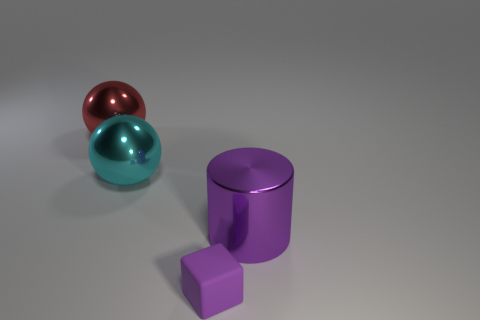Add 2 small purple matte things. How many objects exist? 6 Subtract all cubes. How many objects are left? 3 Subtract all small blue rubber objects. Subtract all matte blocks. How many objects are left? 3 Add 4 large shiny cylinders. How many large shiny cylinders are left? 5 Add 4 large gray balls. How many large gray balls exist? 4 Subtract 0 brown cylinders. How many objects are left? 4 